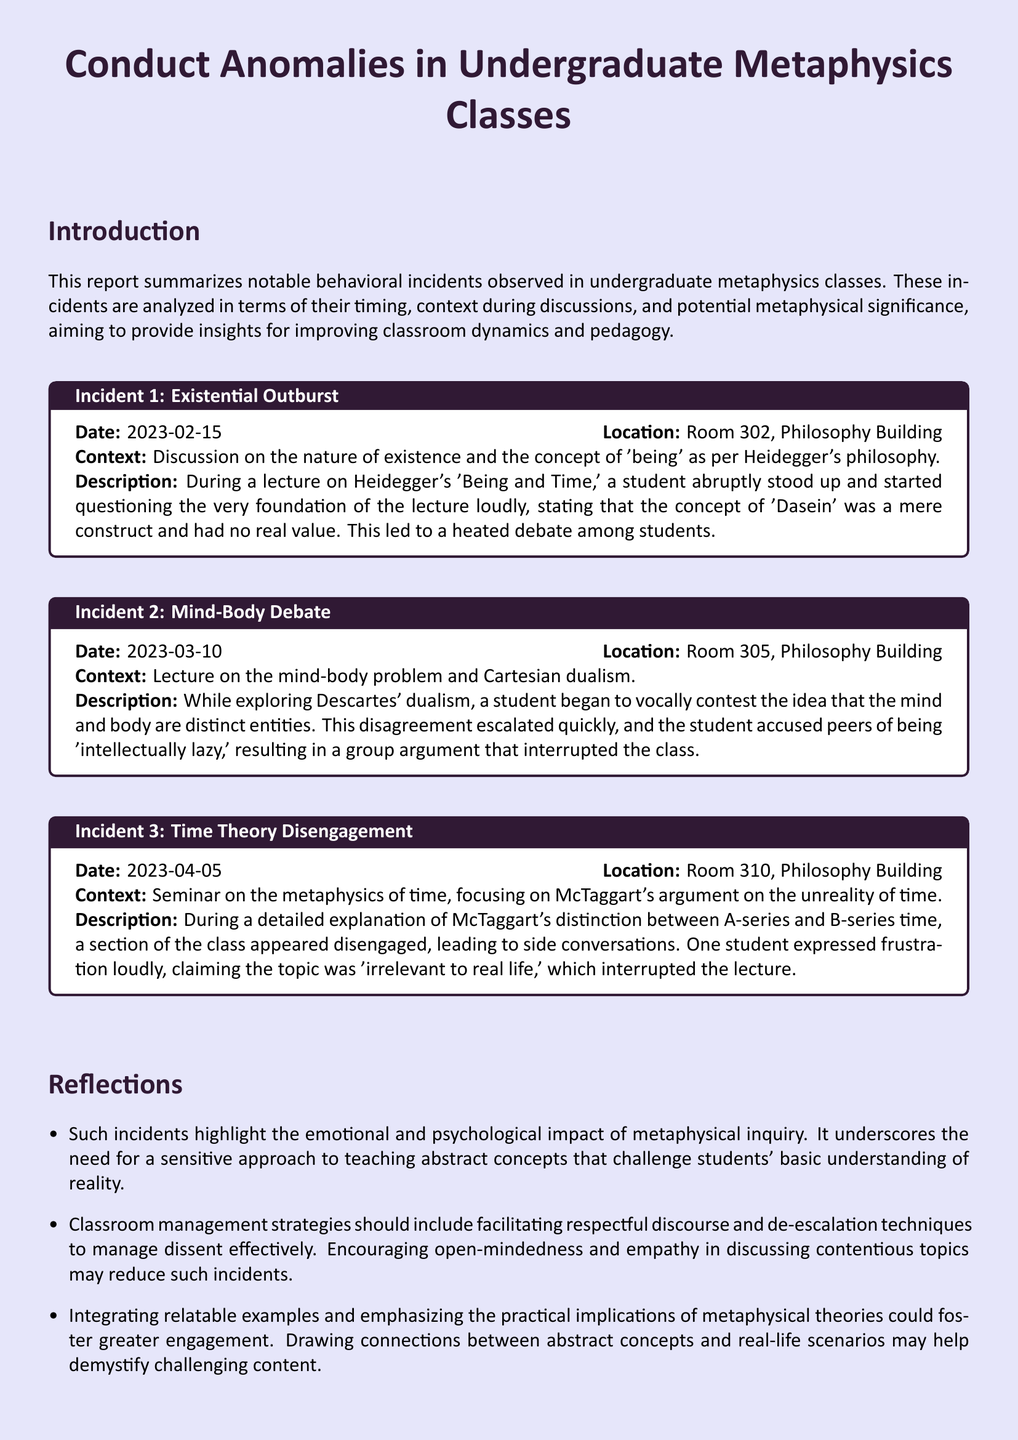What was the date of the existential outburst incident? The incident occurred on the date specified in the document under Incident 1, which is February 15, 2023.
Answer: February 15, 2023 What room did the mind-body debate take place in? The mind-body debate incident is mentioned to have occurred in Room 305, as noted in the document under Incident 2.
Answer: Room 305 What philosophical concept was being discussed during Incident 3? The seminar covered the metaphysics of time, particularly focusing on McTaggart's argument, as described in the document under Incident 3.
Answer: McTaggart's argument on the unreality of time How many notable incidents are recorded in the document? The document contains a summary of three notable behavioral incidents, which can be counted from the incidents listed.
Answer: Three What is the primary reflection suggested in the report? The reflections section discusses the emotional impact of metaphysical inquiry and the need for a sensitive teaching approach, which is summarized in the guidance provided.
Answer: Sensitive approach to teaching abstract concepts What was a key point of contention during the mind-body debate? The key point during the debate was the distinction between mind and body, which led a student to accuse others of being 'intellectually lazy.'
Answer: Distinction between mind and body What kind of incidents does the report summarize? The document summarizes behavioral incidents observed in undergraduate metaphysics classes.
Answer: Behavioral incidents What type of course was the subject of Incident 1? Incident 1 took place during a lecture on Heidegger's philosophy, specifically addressing existence and 'Dasein.'
Answer: Lecture on Heidegger's philosophy 